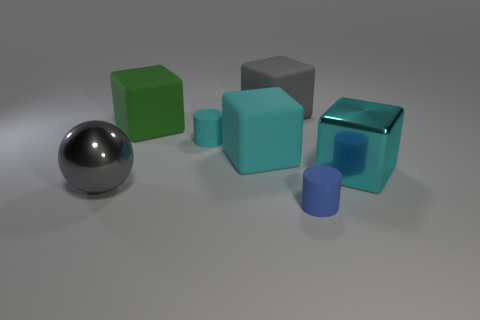Subtract all gray cylinders. How many cyan cubes are left? 2 Subtract all large green rubber blocks. How many blocks are left? 3 Add 1 purple shiny cylinders. How many objects exist? 8 Subtract all gray blocks. How many blocks are left? 3 Subtract all blocks. How many objects are left? 3 Subtract all blue blocks. Subtract all yellow spheres. How many blocks are left? 4 Add 5 small cyan rubber things. How many small cyan rubber things exist? 6 Subtract 1 green cubes. How many objects are left? 6 Subtract all cyan matte objects. Subtract all cyan rubber cubes. How many objects are left? 4 Add 2 green objects. How many green objects are left? 3 